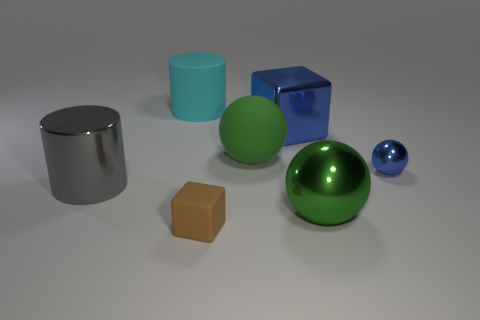What shape is the small object that is the same color as the big metallic block?
Make the answer very short. Sphere. What is the shape of the small object in front of the small ball?
Keep it short and to the point. Cube. Is the shape of the big rubber thing behind the large blue thing the same as  the small metallic object?
Provide a succinct answer. No. How many objects are either large metal objects in front of the small blue thing or big shiny things?
Ensure brevity in your answer.  3. What is the color of the large metallic object that is the same shape as the green rubber thing?
Keep it short and to the point. Green. Are there any other things that have the same color as the small sphere?
Keep it short and to the point. Yes. There is a shiny object that is behind the green matte sphere; what size is it?
Provide a short and direct response. Large. Do the matte cube and the large metal thing left of the large block have the same color?
Give a very brief answer. No. How many other objects are there of the same material as the brown thing?
Keep it short and to the point. 2. Is the number of purple rubber objects greater than the number of brown rubber objects?
Give a very brief answer. No. 